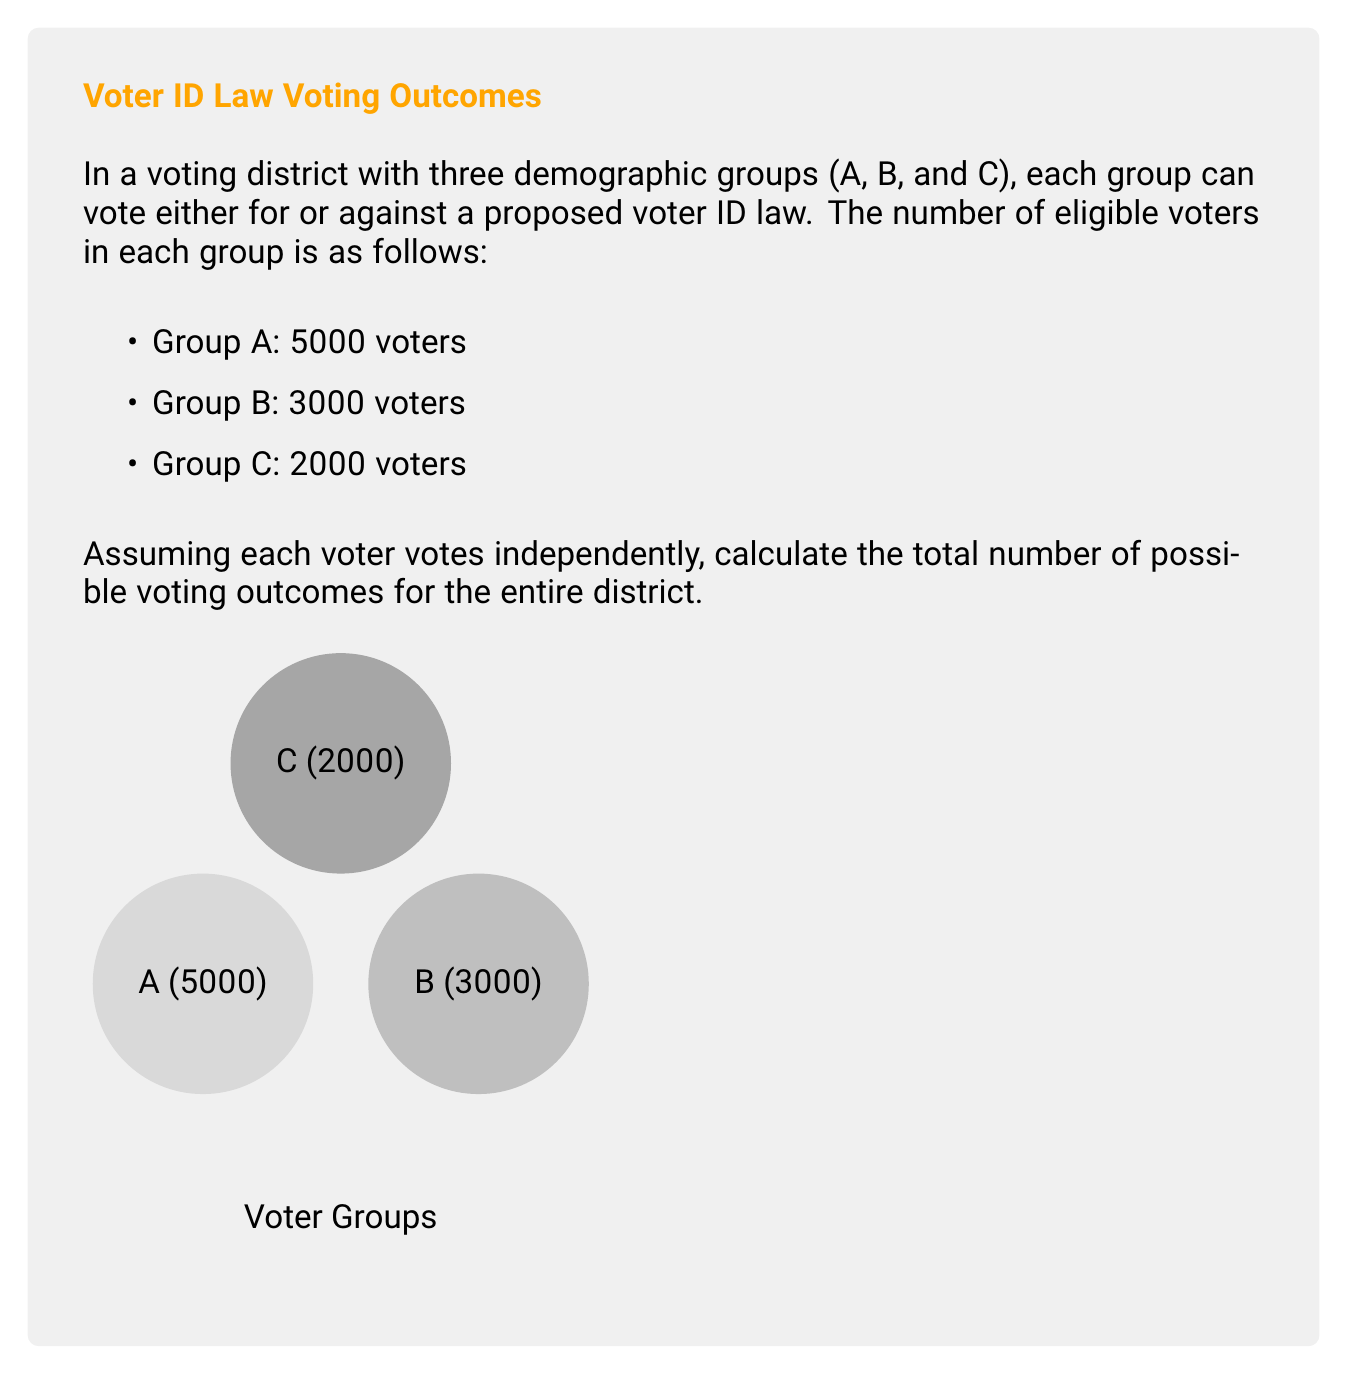Show me your answer to this math problem. To solve this problem, we need to use the multiplication principle of combinatorics. Let's break it down step-by-step:

1) For each individual voter, there are 2 possible outcomes: voting for or against the law.

2) For each demographic group:
   - Group A: $2^{5000}$ possible outcomes
   - Group B: $2^{3000}$ possible outcomes
   - Group C: $2^{2000}$ possible outcomes

3) Since we want the total number of possible outcomes for the entire district, we need to consider all combinations of outcomes from each group.

4) According to the multiplication principle, when we have independent events, we multiply the number of possibilities for each event to get the total number of possible outcomes.

5) Therefore, the total number of possible voting outcomes for the entire district is:

   $$ 2^{5000} \times 2^{3000} \times 2^{2000} $$

6) Using the laws of exponents, we can simplify this:

   $$ 2^{5000 + 3000 + 2000} = 2^{10000} $$

This represents the total number of possible ways the entire district could vote, considering all individual voter choices.
Answer: $2^{10000}$ 